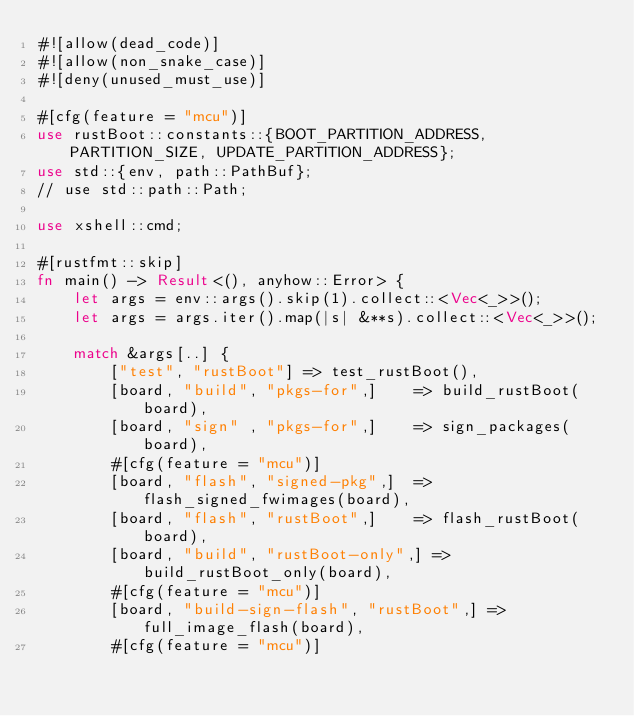<code> <loc_0><loc_0><loc_500><loc_500><_Rust_>#![allow(dead_code)]
#![allow(non_snake_case)]
#![deny(unused_must_use)]

#[cfg(feature = "mcu")]
use rustBoot::constants::{BOOT_PARTITION_ADDRESS, PARTITION_SIZE, UPDATE_PARTITION_ADDRESS};
use std::{env, path::PathBuf};
// use std::path::Path;

use xshell::cmd;

#[rustfmt::skip]
fn main() -> Result<(), anyhow::Error> {
    let args = env::args().skip(1).collect::<Vec<_>>();
    let args = args.iter().map(|s| &**s).collect::<Vec<_>>();
    
    match &args[..] {
        ["test", "rustBoot"] => test_rustBoot(),
        [board, "build", "pkgs-for",]    => build_rustBoot(board),
        [board, "sign" , "pkgs-for",]    => sign_packages(board),
        #[cfg(feature = "mcu")]
        [board, "flash", "signed-pkg",]  => flash_signed_fwimages(board),
        [board, "flash", "rustBoot",]    => flash_rustBoot(board),
        [board, "build", "rustBoot-only",] => build_rustBoot_only(board),
        #[cfg(feature = "mcu")]
        [board, "build-sign-flash", "rustBoot",] => full_image_flash(board),
        #[cfg(feature = "mcu")]</code> 